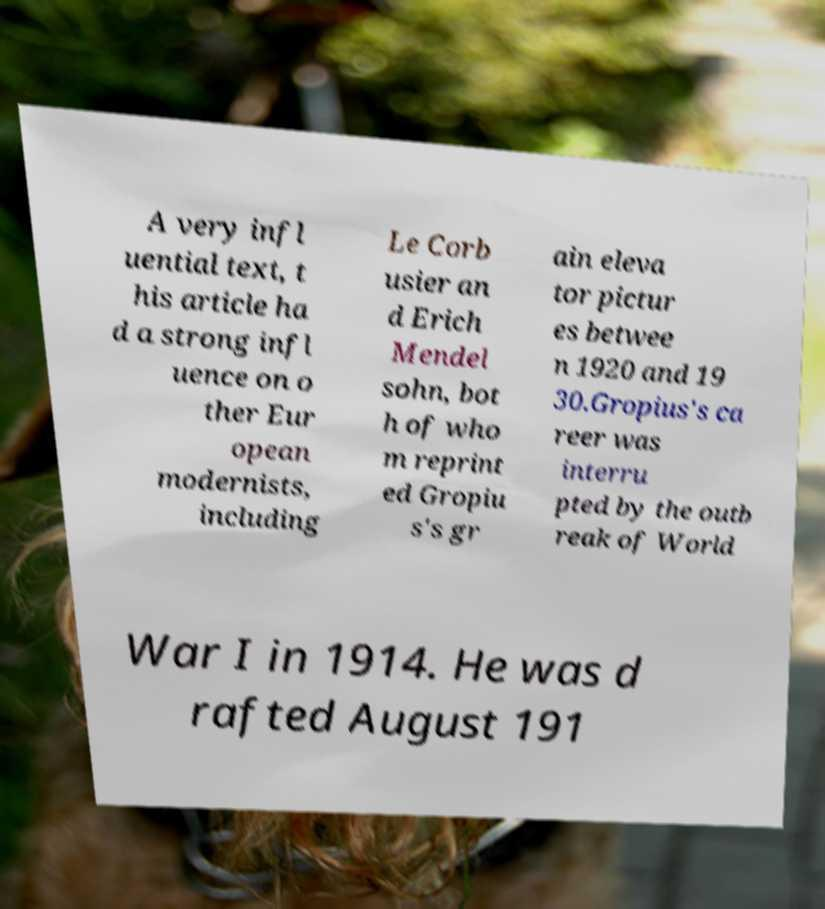Please identify and transcribe the text found in this image. A very infl uential text, t his article ha d a strong infl uence on o ther Eur opean modernists, including Le Corb usier an d Erich Mendel sohn, bot h of who m reprint ed Gropiu s's gr ain eleva tor pictur es betwee n 1920 and 19 30.Gropius's ca reer was interru pted by the outb reak of World War I in 1914. He was d rafted August 191 